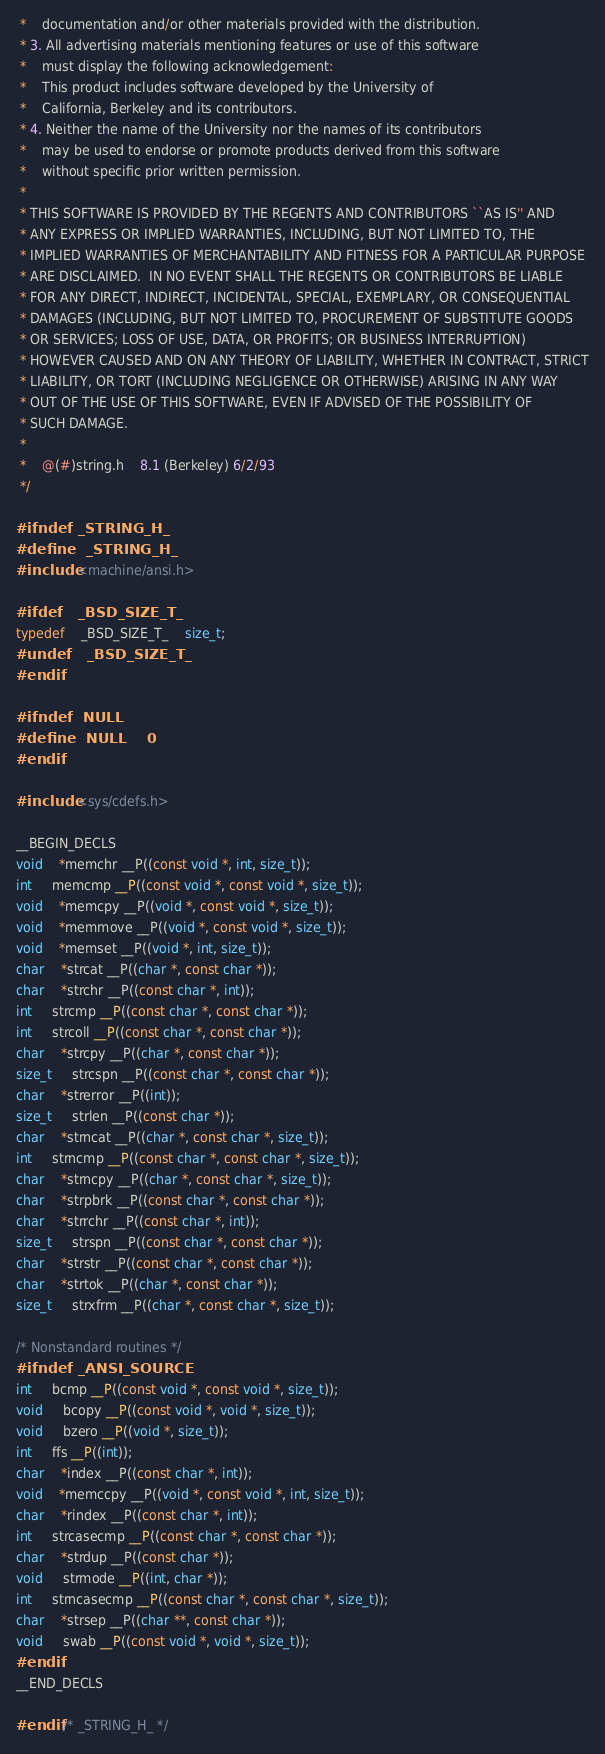Convert code to text. <code><loc_0><loc_0><loc_500><loc_500><_C_> *    documentation and/or other materials provided with the distribution.
 * 3. All advertising materials mentioning features or use of this software
 *    must display the following acknowledgement:
 *	This product includes software developed by the University of
 *	California, Berkeley and its contributors.
 * 4. Neither the name of the University nor the names of its contributors
 *    may be used to endorse or promote products derived from this software
 *    without specific prior written permission.
 *
 * THIS SOFTWARE IS PROVIDED BY THE REGENTS AND CONTRIBUTORS ``AS IS'' AND
 * ANY EXPRESS OR IMPLIED WARRANTIES, INCLUDING, BUT NOT LIMITED TO, THE
 * IMPLIED WARRANTIES OF MERCHANTABILITY AND FITNESS FOR A PARTICULAR PURPOSE
 * ARE DISCLAIMED.  IN NO EVENT SHALL THE REGENTS OR CONTRIBUTORS BE LIABLE
 * FOR ANY DIRECT, INDIRECT, INCIDENTAL, SPECIAL, EXEMPLARY, OR CONSEQUENTIAL
 * DAMAGES (INCLUDING, BUT NOT LIMITED TO, PROCUREMENT OF SUBSTITUTE GOODS
 * OR SERVICES; LOSS OF USE, DATA, OR PROFITS; OR BUSINESS INTERRUPTION)
 * HOWEVER CAUSED AND ON ANY THEORY OF LIABILITY, WHETHER IN CONTRACT, STRICT
 * LIABILITY, OR TORT (INCLUDING NEGLIGENCE OR OTHERWISE) ARISING IN ANY WAY
 * OUT OF THE USE OF THIS SOFTWARE, EVEN IF ADVISED OF THE POSSIBILITY OF
 * SUCH DAMAGE.
 *
 *	@(#)string.h	8.1 (Berkeley) 6/2/93
 */

#ifndef _STRING_H_
#define	_STRING_H_
#include <machine/ansi.h>

#ifdef	_BSD_SIZE_T_
typedef	_BSD_SIZE_T_	size_t;
#undef	_BSD_SIZE_T_
#endif

#ifndef	NULL
#define	NULL	0
#endif

#include <sys/cdefs.h>

__BEGIN_DECLS
void	*memchr __P((const void *, int, size_t));
int	 memcmp __P((const void *, const void *, size_t));
void	*memcpy __P((void *, const void *, size_t));
void	*memmove __P((void *, const void *, size_t));
void	*memset __P((void *, int, size_t));
char	*strcat __P((char *, const char *));
char	*strchr __P((const char *, int));
int	 strcmp __P((const char *, const char *));
int	 strcoll __P((const char *, const char *));
char	*strcpy __P((char *, const char *));
size_t	 strcspn __P((const char *, const char *));
char	*strerror __P((int));
size_t	 strlen __P((const char *));
char	*strncat __P((char *, const char *, size_t));
int	 strncmp __P((const char *, const char *, size_t));
char	*strncpy __P((char *, const char *, size_t));
char	*strpbrk __P((const char *, const char *));
char	*strrchr __P((const char *, int));
size_t	 strspn __P((const char *, const char *));
char	*strstr __P((const char *, const char *));
char	*strtok __P((char *, const char *));
size_t	 strxfrm __P((char *, const char *, size_t));

/* Nonstandard routines */
#ifndef _ANSI_SOURCE
int	 bcmp __P((const void *, const void *, size_t));
void	 bcopy __P((const void *, void *, size_t));
void	 bzero __P((void *, size_t));
int	 ffs __P((int));
char	*index __P((const char *, int));
void	*memccpy __P((void *, const void *, int, size_t));
char	*rindex __P((const char *, int));
int	 strcasecmp __P((const char *, const char *));
char	*strdup __P((const char *));
void	 strmode __P((int, char *));
int	 strncasecmp __P((const char *, const char *, size_t));
char	*strsep __P((char **, const char *));
void	 swab __P((const void *, void *, size_t));
#endif 
__END_DECLS

#endif /* _STRING_H_ */
</code> 